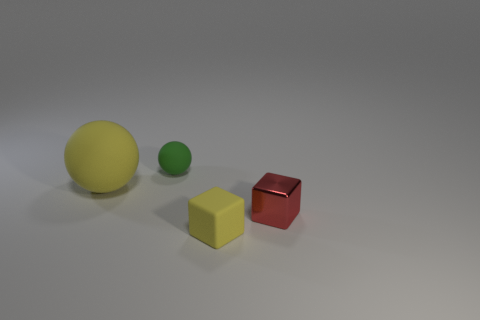What shape is the red shiny thing that is the same size as the green matte sphere?
Provide a short and direct response. Cube. Is the number of big gray matte cylinders less than the number of small green matte objects?
Your answer should be compact. Yes. Is there a yellow matte object that is on the right side of the rubber sphere behind the large yellow rubber sphere?
Keep it short and to the point. Yes. Is there a yellow rubber object in front of the block to the right of the small object in front of the small red metallic cube?
Your response must be concise. Yes. Does the thing on the left side of the green ball have the same shape as the tiny matte object that is to the left of the yellow matte block?
Your answer should be compact. Yes. The large ball that is the same material as the small green thing is what color?
Your answer should be compact. Yellow. Are there fewer green matte things that are to the right of the small red thing than big purple matte cubes?
Your response must be concise. No. There is a yellow matte object that is to the left of the small matte object in front of the tiny matte object behind the tiny red shiny object; what size is it?
Offer a very short reply. Large. Are the yellow thing that is in front of the metal thing and the big yellow sphere made of the same material?
Offer a terse response. Yes. What number of things are either yellow matte cubes or metal things?
Your answer should be compact. 2. 